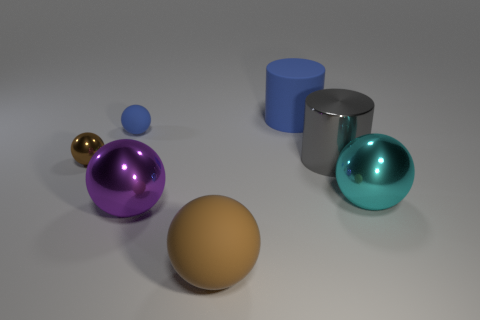Subtract all brown balls. How many balls are left? 3 Add 1 purple rubber cylinders. How many objects exist? 8 Subtract all gray cylinders. How many brown balls are left? 2 Subtract all blue cylinders. How many cylinders are left? 1 Add 6 big cyan spheres. How many big cyan spheres are left? 7 Add 4 large green cubes. How many large green cubes exist? 4 Subtract 0 yellow cubes. How many objects are left? 7 Subtract all cylinders. How many objects are left? 5 Subtract 2 cylinders. How many cylinders are left? 0 Subtract all gray spheres. Subtract all red cylinders. How many spheres are left? 5 